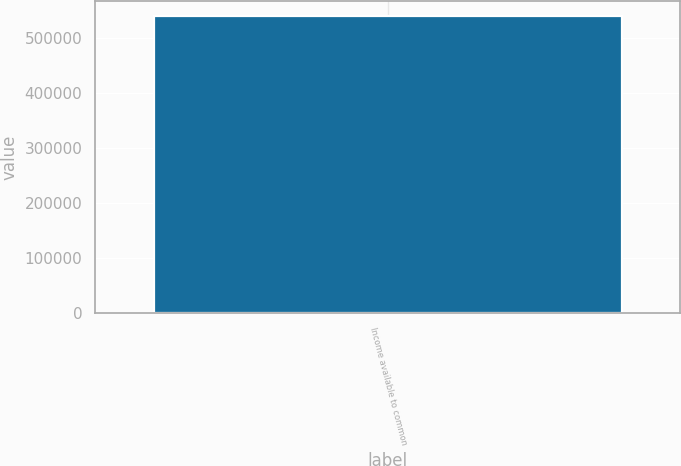<chart> <loc_0><loc_0><loc_500><loc_500><bar_chart><fcel>Income available to common<nl><fcel>539362<nl></chart> 